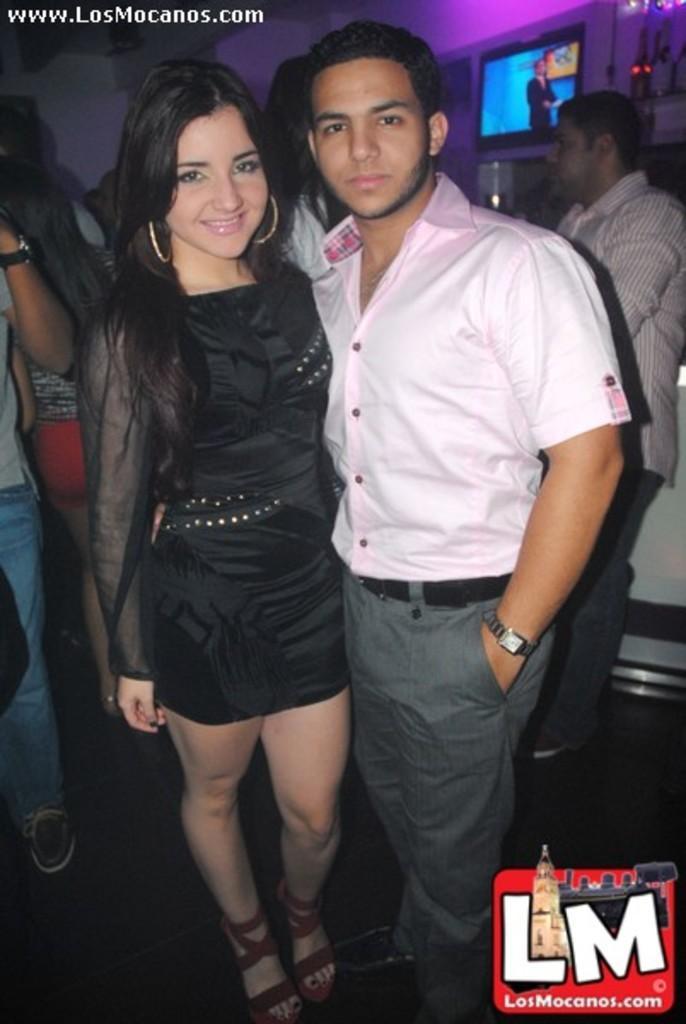Could you give a brief overview of what you see in this image? On the bottom right, there is a watermark. On the top left, there is a watermark. In the middle of this image, there is a woman in a black color dress, smiling and standing. Beside her, there is a person standing. In the background, there are other persons, there is a screen, there are lights arranged and there is a wall. 